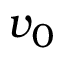Convert formula to latex. <formula><loc_0><loc_0><loc_500><loc_500>v _ { 0 }</formula> 